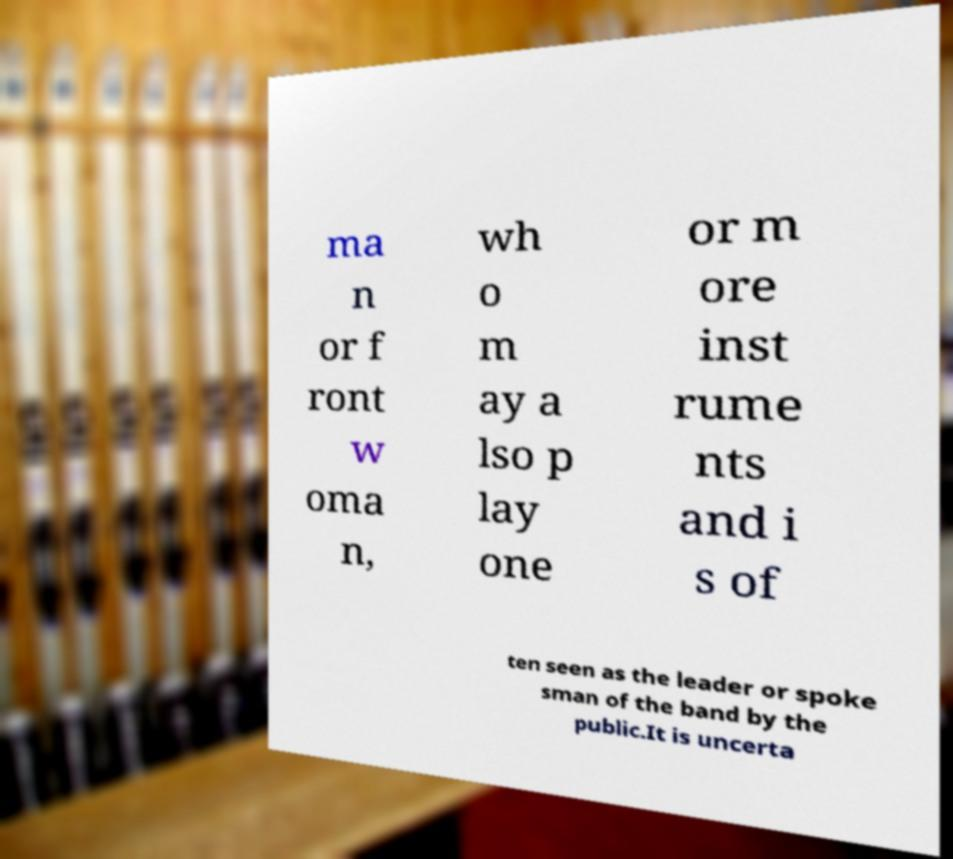I need the written content from this picture converted into text. Can you do that? ma n or f ront w oma n, wh o m ay a lso p lay one or m ore inst rume nts and i s of ten seen as the leader or spoke sman of the band by the public.It is uncerta 